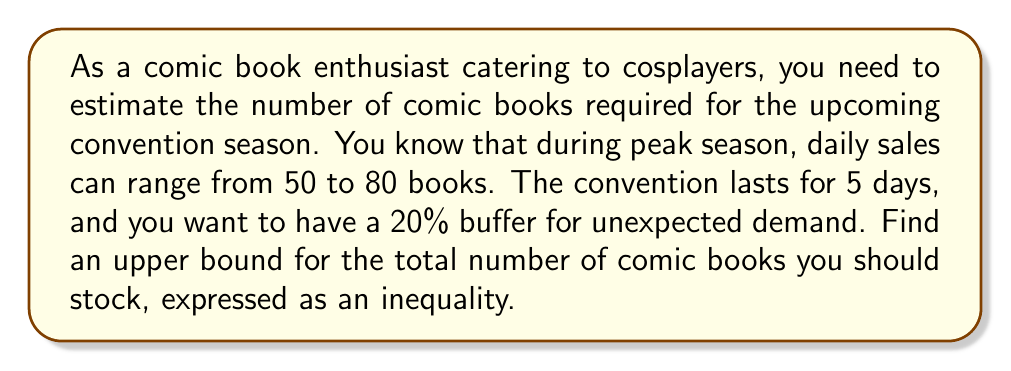Can you answer this question? Let's approach this step-by-step:

1) First, let's consider the daily sales range:
   $50 \leq \text{daily sales} \leq 80$

2) The convention lasts for 5 days, so we multiply the upper bound by 5:
   $\text{Total sales for 5 days} \leq 80 \times 5 = 400$

3) Now, we need to add a 20% buffer. To calculate this:
   $\text{Buffer} = 20\% \text{ of } 400 = 0.2 \times 400 = 80$

4) Adding this buffer to our total:
   $\text{Total stock} \leq 400 + 80 = 480$

5) Since we're looking for an upper bound and dealing with whole comic books, we can round up to the nearest integer:
   $\text{Total stock} \leq 480$

Therefore, the inequality representing the upper bound of comic books you should stock is:

$$x \leq 480$$

where $x$ represents the number of comic books to stock.
Answer: $x \leq 480$, where $x$ is the number of comic books to stock. 